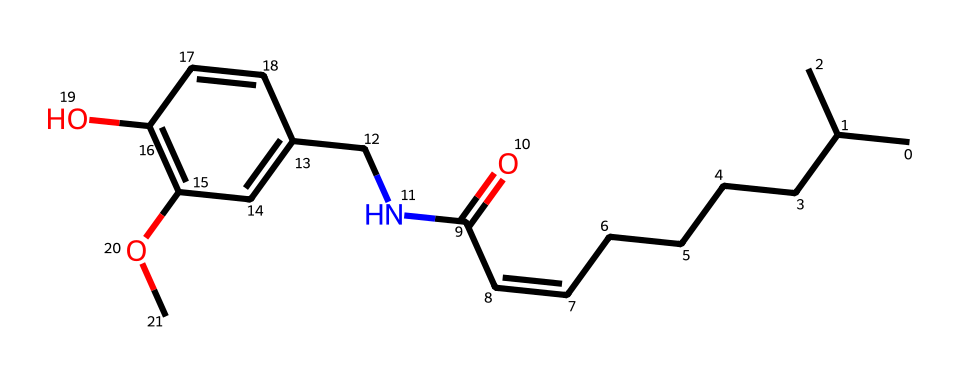what is the name of this chemical? The chemical with the given SMILES representation is capsaicin, which is known for its spicy flavor in foods.
Answer: capsaicin how many carbon atoms are in this molecule? By analyzing the SMILES representation, we can count the number of carbon (C) atoms present. The representation shows there are 18 carbon atoms.
Answer: 18 how many nitrogen atoms are present in capsaicin? The SMILES structure contains one nitrogen (N) atom, identifiable from the presence of the nitrogen symbol.
Answer: 1 what functional group is present in this molecule? The molecule contains an amide functional group due to the presence of the carbonyl (C=O) and the nitrogen (N) atom connected next to it.
Answer: amide is this molecule classified as a saturated or unsaturated compound? The presence of a double bond in the structure, indicated in the SMILES with "C=C", signifies that capsaicin is an unsaturated compound.
Answer: unsaturated what is the primary effect of capsaicin on the human body? Capsaicin primarily causes a sensation of heat or spiciness when consumed, activating pain receptors in the mouth.
Answer: heat sensation how does the structure of capsaicin relate to its spiciness? The structure features a long hydrocarbon chain and the functional groups that interact with receptors responsible for detecting temperature and pain, causing the sensation of spiciness.
Answer: receptor interaction 